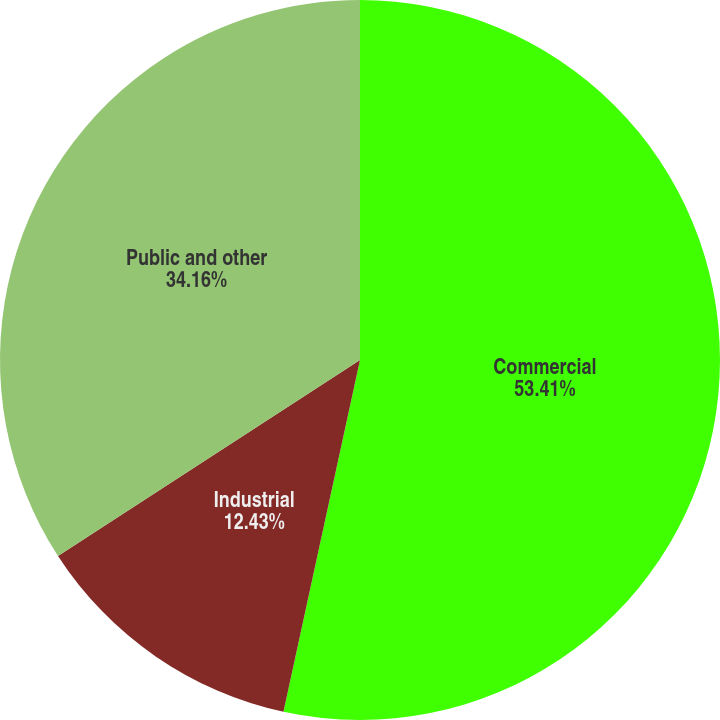<chart> <loc_0><loc_0><loc_500><loc_500><pie_chart><fcel>Commercial<fcel>Industrial<fcel>Public and other<nl><fcel>53.41%<fcel>12.43%<fcel>34.16%<nl></chart> 